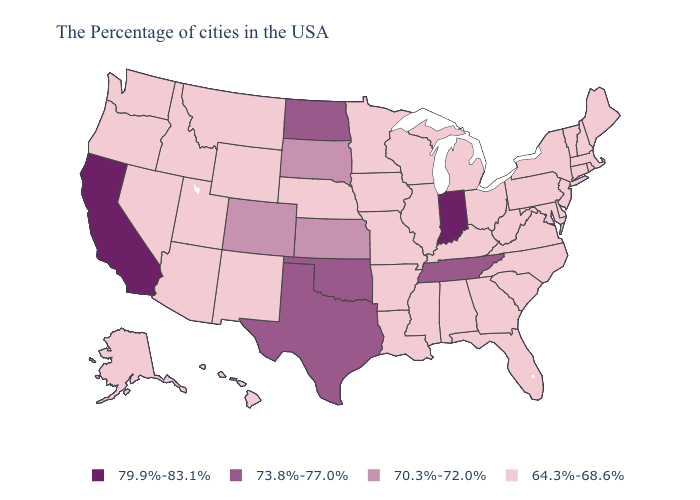Does North Carolina have a higher value than Tennessee?
Keep it brief. No. Name the states that have a value in the range 79.9%-83.1%?
Give a very brief answer. Indiana, California. Which states have the lowest value in the USA?
Quick response, please. Maine, Massachusetts, Rhode Island, New Hampshire, Vermont, Connecticut, New York, New Jersey, Delaware, Maryland, Pennsylvania, Virginia, North Carolina, South Carolina, West Virginia, Ohio, Florida, Georgia, Michigan, Kentucky, Alabama, Wisconsin, Illinois, Mississippi, Louisiana, Missouri, Arkansas, Minnesota, Iowa, Nebraska, Wyoming, New Mexico, Utah, Montana, Arizona, Idaho, Nevada, Washington, Oregon, Alaska, Hawaii. Does Tennessee have the lowest value in the USA?
Short answer required. No. Does North Dakota have the lowest value in the MidWest?
Quick response, please. No. What is the value of Connecticut?
Be succinct. 64.3%-68.6%. What is the value of Utah?
Be succinct. 64.3%-68.6%. Name the states that have a value in the range 79.9%-83.1%?
Give a very brief answer. Indiana, California. Does California have the lowest value in the USA?
Answer briefly. No. Name the states that have a value in the range 64.3%-68.6%?
Be succinct. Maine, Massachusetts, Rhode Island, New Hampshire, Vermont, Connecticut, New York, New Jersey, Delaware, Maryland, Pennsylvania, Virginia, North Carolina, South Carolina, West Virginia, Ohio, Florida, Georgia, Michigan, Kentucky, Alabama, Wisconsin, Illinois, Mississippi, Louisiana, Missouri, Arkansas, Minnesota, Iowa, Nebraska, Wyoming, New Mexico, Utah, Montana, Arizona, Idaho, Nevada, Washington, Oregon, Alaska, Hawaii. Does Kansas have the lowest value in the USA?
Concise answer only. No. What is the value of North Carolina?
Be succinct. 64.3%-68.6%. What is the value of South Dakota?
Give a very brief answer. 70.3%-72.0%. Name the states that have a value in the range 73.8%-77.0%?
Short answer required. Tennessee, Oklahoma, Texas, North Dakota. Among the states that border Wyoming , which have the lowest value?
Concise answer only. Nebraska, Utah, Montana, Idaho. 